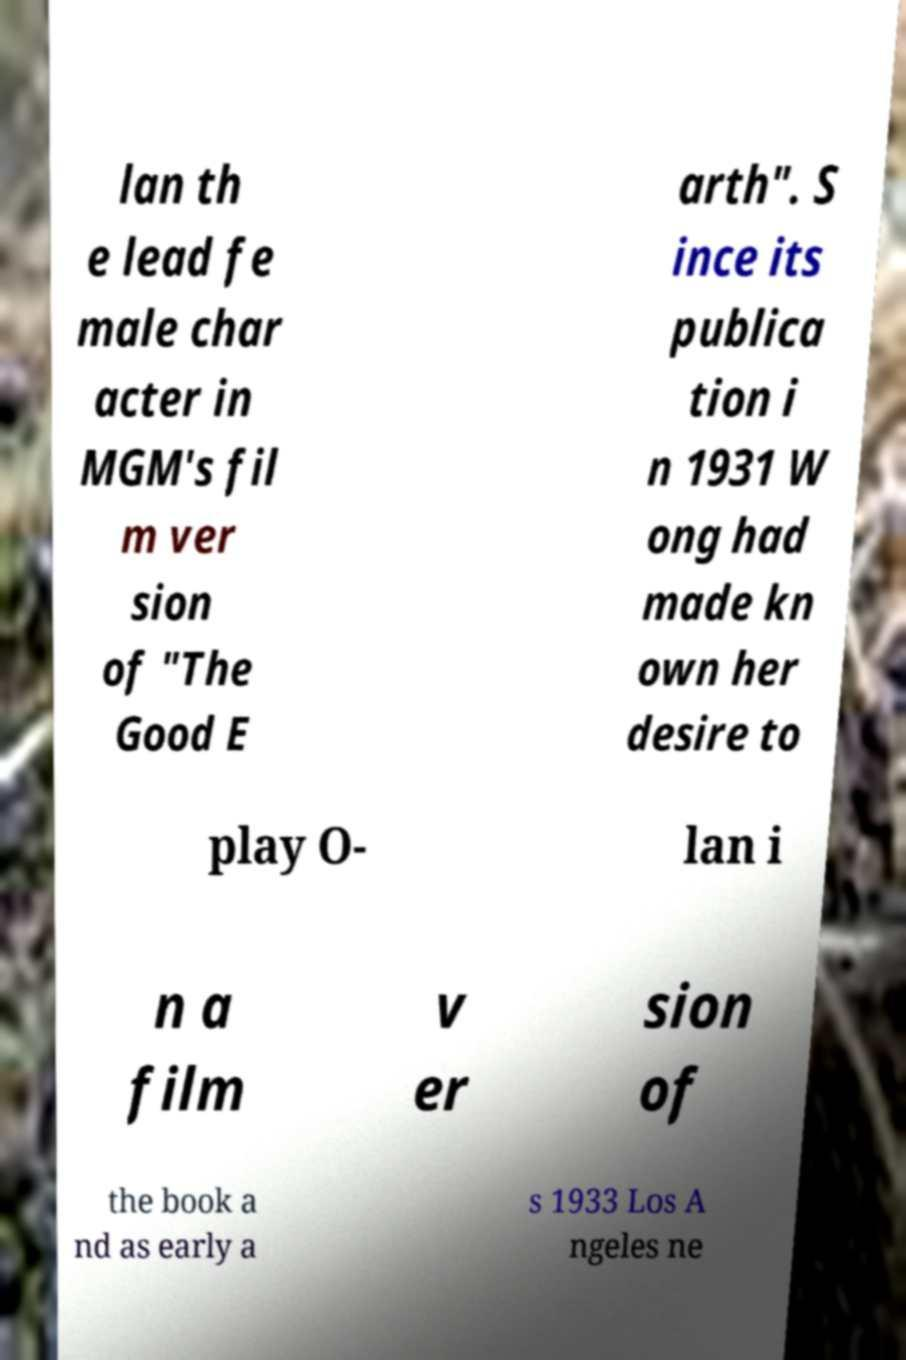Please read and relay the text visible in this image. What does it say? lan th e lead fe male char acter in MGM's fil m ver sion of "The Good E arth". S ince its publica tion i n 1931 W ong had made kn own her desire to play O- lan i n a film v er sion of the book a nd as early a s 1933 Los A ngeles ne 